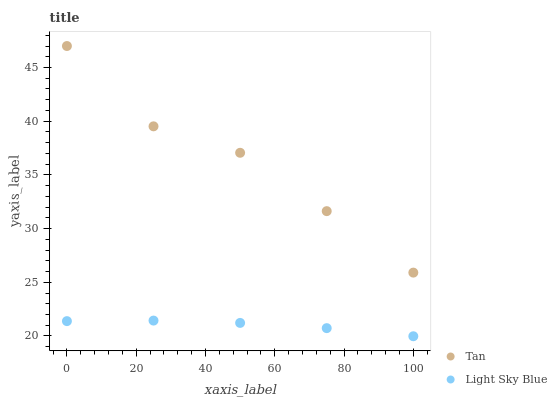Does Light Sky Blue have the minimum area under the curve?
Answer yes or no. Yes. Does Tan have the maximum area under the curve?
Answer yes or no. Yes. Does Light Sky Blue have the maximum area under the curve?
Answer yes or no. No. Is Light Sky Blue the smoothest?
Answer yes or no. Yes. Is Tan the roughest?
Answer yes or no. Yes. Is Light Sky Blue the roughest?
Answer yes or no. No. Does Light Sky Blue have the lowest value?
Answer yes or no. Yes. Does Tan have the highest value?
Answer yes or no. Yes. Does Light Sky Blue have the highest value?
Answer yes or no. No. Is Light Sky Blue less than Tan?
Answer yes or no. Yes. Is Tan greater than Light Sky Blue?
Answer yes or no. Yes. Does Light Sky Blue intersect Tan?
Answer yes or no. No. 